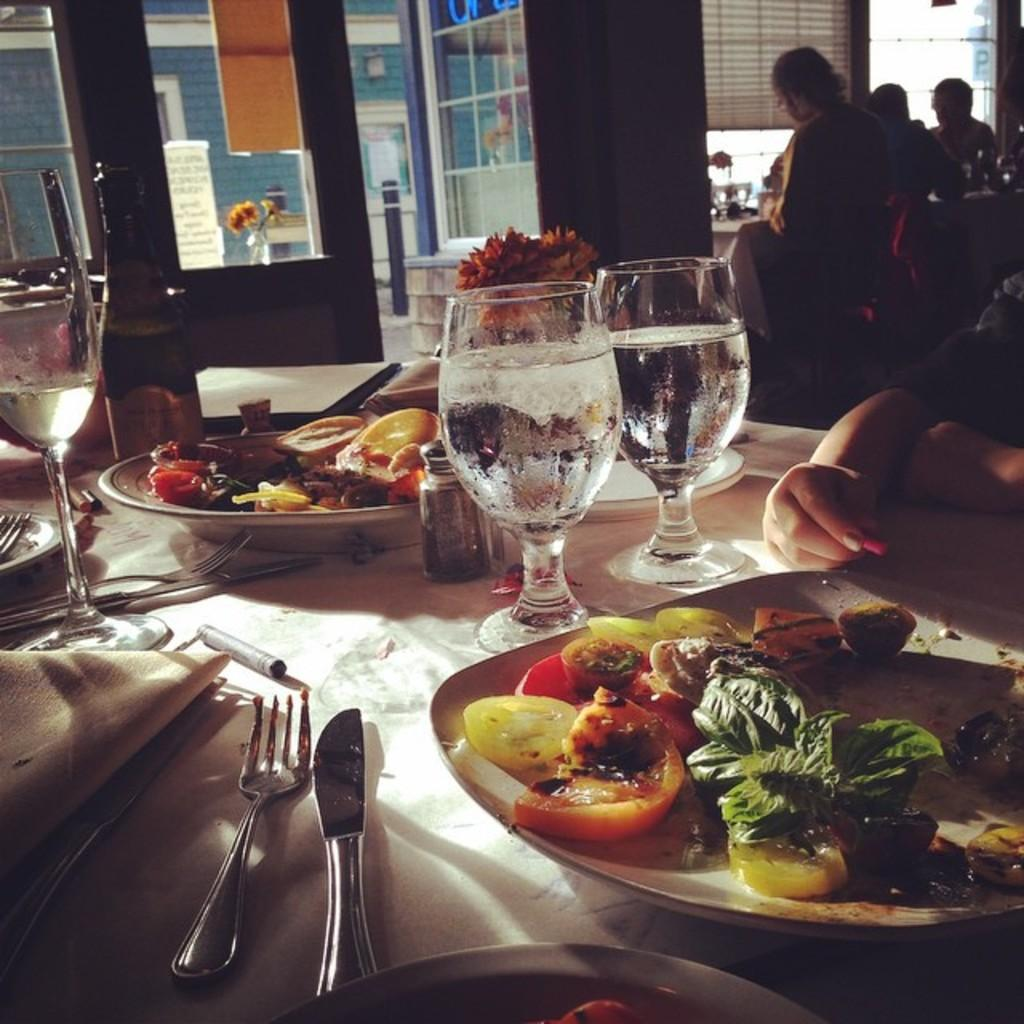What piece of furniture is present in the image? There is a table in the image. What is placed on the table? There is a plate on the table, and there are food items on the plate. What utensils are present on the table? There is a fork and a spoon on the table. What decorative item is on the table? There is a flower vase on the table. What can be seen in the background of the image? There is a window and cupboards in the background of the image. Is there a basketball game happening in the background of the image? No, there is no basketball game or any reference to a basketball in the image. 